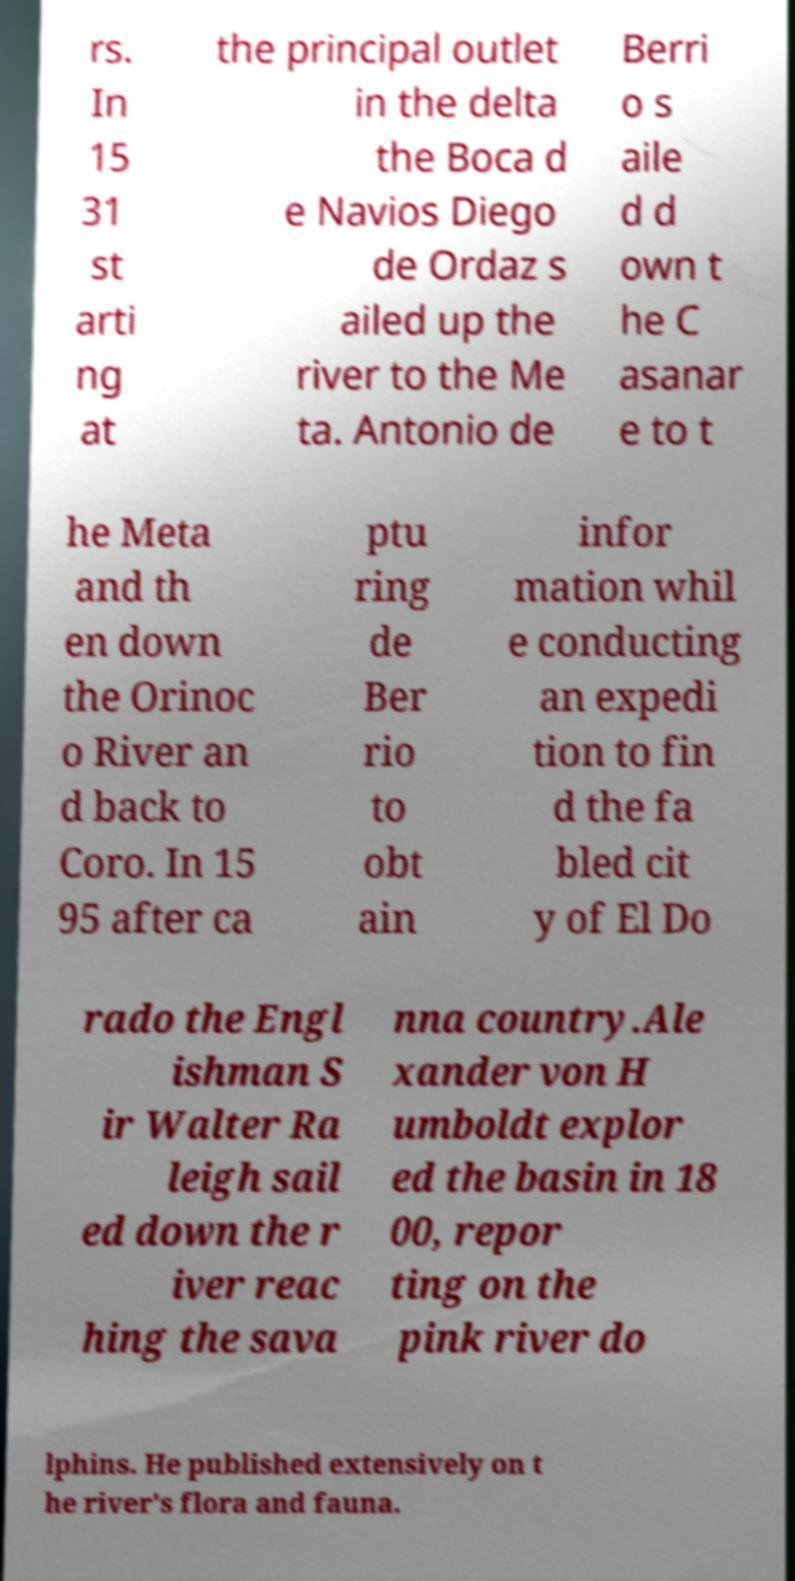Can you read and provide the text displayed in the image?This photo seems to have some interesting text. Can you extract and type it out for me? rs. In 15 31 st arti ng at the principal outlet in the delta the Boca d e Navios Diego de Ordaz s ailed up the river to the Me ta. Antonio de Berri o s aile d d own t he C asanar e to t he Meta and th en down the Orinoc o River an d back to Coro. In 15 95 after ca ptu ring de Ber rio to obt ain infor mation whil e conducting an expedi tion to fin d the fa bled cit y of El Do rado the Engl ishman S ir Walter Ra leigh sail ed down the r iver reac hing the sava nna country.Ale xander von H umboldt explor ed the basin in 18 00, repor ting on the pink river do lphins. He published extensively on t he river's flora and fauna. 